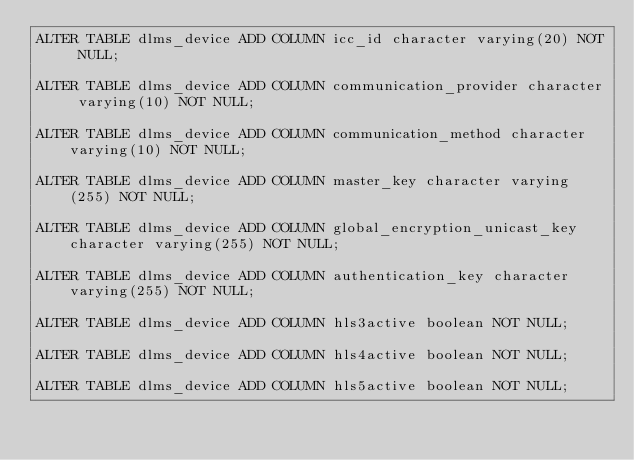Convert code to text. <code><loc_0><loc_0><loc_500><loc_500><_SQL_>ALTER TABLE dlms_device ADD COLUMN icc_id character varying(20) NOT NULL;

ALTER TABLE dlms_device ADD COLUMN communication_provider character varying(10) NOT NULL;

ALTER TABLE dlms_device ADD COLUMN communication_method character varying(10) NOT NULL;

ALTER TABLE dlms_device ADD COLUMN master_key character varying(255) NOT NULL;

ALTER TABLE dlms_device ADD COLUMN global_encryption_unicast_key character varying(255) NOT NULL;

ALTER TABLE dlms_device ADD COLUMN authentication_key character varying(255) NOT NULL;

ALTER TABLE dlms_device ADD COLUMN hls3active boolean NOT NULL;

ALTER TABLE dlms_device ADD COLUMN hls4active boolean NOT NULL;

ALTER TABLE dlms_device ADD COLUMN hls5active boolean NOT NULL;
</code> 